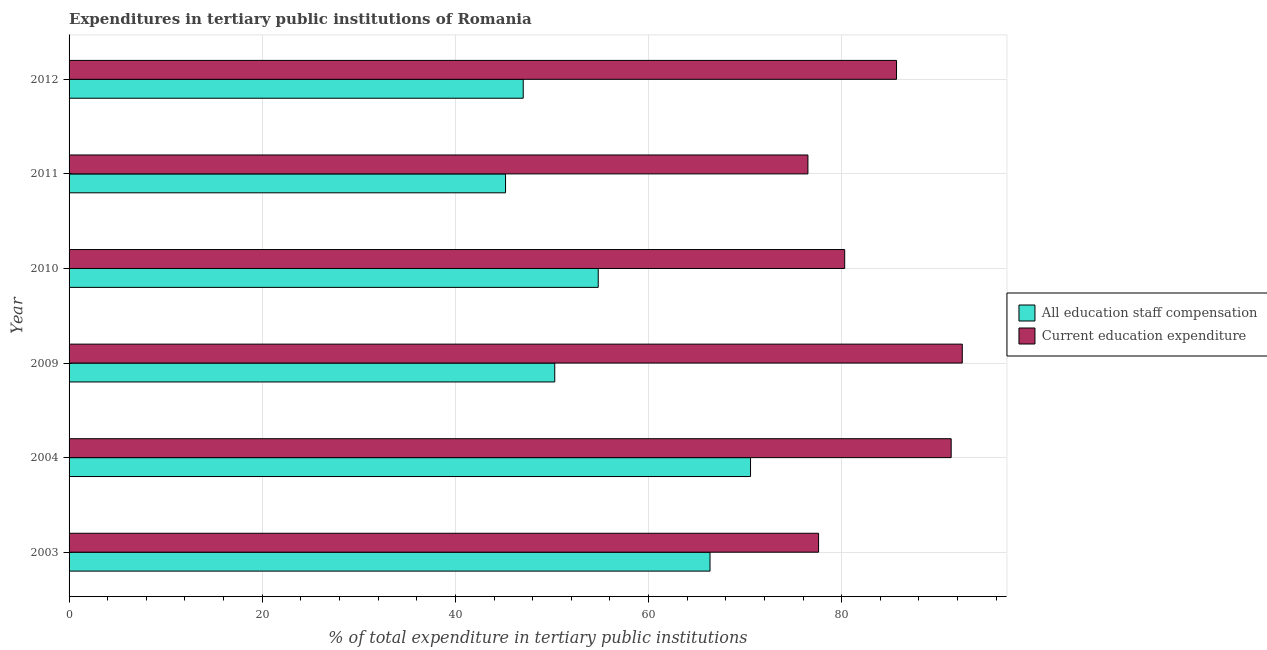How many different coloured bars are there?
Your response must be concise. 2. How many groups of bars are there?
Provide a short and direct response. 6. Are the number of bars on each tick of the Y-axis equal?
Keep it short and to the point. Yes. How many bars are there on the 5th tick from the top?
Offer a terse response. 2. What is the label of the 1st group of bars from the top?
Provide a short and direct response. 2012. In how many cases, is the number of bars for a given year not equal to the number of legend labels?
Ensure brevity in your answer.  0. What is the expenditure in staff compensation in 2011?
Your answer should be very brief. 45.19. Across all years, what is the maximum expenditure in staff compensation?
Give a very brief answer. 70.56. Across all years, what is the minimum expenditure in staff compensation?
Give a very brief answer. 45.19. What is the total expenditure in staff compensation in the graph?
Your response must be concise. 334.21. What is the difference between the expenditure in education in 2010 and that in 2012?
Keep it short and to the point. -5.37. What is the difference between the expenditure in education in 2009 and the expenditure in staff compensation in 2003?
Give a very brief answer. 26.12. What is the average expenditure in education per year?
Your answer should be very brief. 83.98. In the year 2012, what is the difference between the expenditure in education and expenditure in staff compensation?
Your response must be concise. 38.65. In how many years, is the expenditure in education greater than 64 %?
Provide a succinct answer. 6. What is the ratio of the expenditure in staff compensation in 2010 to that in 2011?
Ensure brevity in your answer.  1.21. Is the expenditure in education in 2004 less than that in 2009?
Keep it short and to the point. Yes. What is the difference between the highest and the second highest expenditure in education?
Your answer should be compact. 1.15. What is the difference between the highest and the lowest expenditure in staff compensation?
Give a very brief answer. 25.36. In how many years, is the expenditure in staff compensation greater than the average expenditure in staff compensation taken over all years?
Provide a succinct answer. 2. Is the sum of the expenditure in staff compensation in 2009 and 2010 greater than the maximum expenditure in education across all years?
Make the answer very short. Yes. What does the 1st bar from the top in 2012 represents?
Make the answer very short. Current education expenditure. What does the 2nd bar from the bottom in 2012 represents?
Ensure brevity in your answer.  Current education expenditure. How many bars are there?
Give a very brief answer. 12. Are all the bars in the graph horizontal?
Offer a very short reply. Yes. How many years are there in the graph?
Offer a very short reply. 6. Are the values on the major ticks of X-axis written in scientific E-notation?
Keep it short and to the point. No. Does the graph contain any zero values?
Offer a terse response. No. How many legend labels are there?
Ensure brevity in your answer.  2. How are the legend labels stacked?
Ensure brevity in your answer.  Vertical. What is the title of the graph?
Your answer should be compact. Expenditures in tertiary public institutions of Romania. Does "Death rate" appear as one of the legend labels in the graph?
Your answer should be compact. No. What is the label or title of the X-axis?
Keep it short and to the point. % of total expenditure in tertiary public institutions. What is the % of total expenditure in tertiary public institutions of All education staff compensation in 2003?
Your answer should be compact. 66.36. What is the % of total expenditure in tertiary public institutions of Current education expenditure in 2003?
Keep it short and to the point. 77.6. What is the % of total expenditure in tertiary public institutions of All education staff compensation in 2004?
Your answer should be compact. 70.56. What is the % of total expenditure in tertiary public institutions in Current education expenditure in 2004?
Your response must be concise. 91.33. What is the % of total expenditure in tertiary public institutions in All education staff compensation in 2009?
Your answer should be very brief. 50.29. What is the % of total expenditure in tertiary public institutions in Current education expenditure in 2009?
Your answer should be very brief. 92.48. What is the % of total expenditure in tertiary public institutions of All education staff compensation in 2010?
Your answer should be compact. 54.79. What is the % of total expenditure in tertiary public institutions in Current education expenditure in 2010?
Make the answer very short. 80.31. What is the % of total expenditure in tertiary public institutions in All education staff compensation in 2011?
Your response must be concise. 45.19. What is the % of total expenditure in tertiary public institutions in Current education expenditure in 2011?
Your answer should be compact. 76.5. What is the % of total expenditure in tertiary public institutions in All education staff compensation in 2012?
Provide a succinct answer. 47.02. What is the % of total expenditure in tertiary public institutions of Current education expenditure in 2012?
Offer a very short reply. 85.68. Across all years, what is the maximum % of total expenditure in tertiary public institutions in All education staff compensation?
Make the answer very short. 70.56. Across all years, what is the maximum % of total expenditure in tertiary public institutions in Current education expenditure?
Provide a short and direct response. 92.48. Across all years, what is the minimum % of total expenditure in tertiary public institutions of All education staff compensation?
Offer a very short reply. 45.19. Across all years, what is the minimum % of total expenditure in tertiary public institutions of Current education expenditure?
Keep it short and to the point. 76.5. What is the total % of total expenditure in tertiary public institutions in All education staff compensation in the graph?
Give a very brief answer. 334.21. What is the total % of total expenditure in tertiary public institutions of Current education expenditure in the graph?
Provide a succinct answer. 503.9. What is the difference between the % of total expenditure in tertiary public institutions in All education staff compensation in 2003 and that in 2004?
Keep it short and to the point. -4.2. What is the difference between the % of total expenditure in tertiary public institutions of Current education expenditure in 2003 and that in 2004?
Offer a terse response. -13.73. What is the difference between the % of total expenditure in tertiary public institutions in All education staff compensation in 2003 and that in 2009?
Ensure brevity in your answer.  16.08. What is the difference between the % of total expenditure in tertiary public institutions of Current education expenditure in 2003 and that in 2009?
Provide a short and direct response. -14.88. What is the difference between the % of total expenditure in tertiary public institutions of All education staff compensation in 2003 and that in 2010?
Provide a succinct answer. 11.57. What is the difference between the % of total expenditure in tertiary public institutions in Current education expenditure in 2003 and that in 2010?
Provide a short and direct response. -2.7. What is the difference between the % of total expenditure in tertiary public institutions in All education staff compensation in 2003 and that in 2011?
Give a very brief answer. 21.17. What is the difference between the % of total expenditure in tertiary public institutions in Current education expenditure in 2003 and that in 2011?
Your answer should be compact. 1.1. What is the difference between the % of total expenditure in tertiary public institutions of All education staff compensation in 2003 and that in 2012?
Provide a short and direct response. 19.34. What is the difference between the % of total expenditure in tertiary public institutions in Current education expenditure in 2003 and that in 2012?
Give a very brief answer. -8.07. What is the difference between the % of total expenditure in tertiary public institutions of All education staff compensation in 2004 and that in 2009?
Ensure brevity in your answer.  20.27. What is the difference between the % of total expenditure in tertiary public institutions of Current education expenditure in 2004 and that in 2009?
Make the answer very short. -1.15. What is the difference between the % of total expenditure in tertiary public institutions of All education staff compensation in 2004 and that in 2010?
Your answer should be very brief. 15.77. What is the difference between the % of total expenditure in tertiary public institutions in Current education expenditure in 2004 and that in 2010?
Your answer should be very brief. 11.03. What is the difference between the % of total expenditure in tertiary public institutions of All education staff compensation in 2004 and that in 2011?
Make the answer very short. 25.36. What is the difference between the % of total expenditure in tertiary public institutions of Current education expenditure in 2004 and that in 2011?
Your answer should be very brief. 14.83. What is the difference between the % of total expenditure in tertiary public institutions of All education staff compensation in 2004 and that in 2012?
Give a very brief answer. 23.54. What is the difference between the % of total expenditure in tertiary public institutions of Current education expenditure in 2004 and that in 2012?
Offer a terse response. 5.66. What is the difference between the % of total expenditure in tertiary public institutions in All education staff compensation in 2009 and that in 2010?
Give a very brief answer. -4.5. What is the difference between the % of total expenditure in tertiary public institutions of Current education expenditure in 2009 and that in 2010?
Your answer should be compact. 12.18. What is the difference between the % of total expenditure in tertiary public institutions in All education staff compensation in 2009 and that in 2011?
Your answer should be very brief. 5.09. What is the difference between the % of total expenditure in tertiary public institutions of Current education expenditure in 2009 and that in 2011?
Keep it short and to the point. 15.98. What is the difference between the % of total expenditure in tertiary public institutions in All education staff compensation in 2009 and that in 2012?
Your response must be concise. 3.26. What is the difference between the % of total expenditure in tertiary public institutions of Current education expenditure in 2009 and that in 2012?
Provide a short and direct response. 6.81. What is the difference between the % of total expenditure in tertiary public institutions of All education staff compensation in 2010 and that in 2011?
Your answer should be very brief. 9.6. What is the difference between the % of total expenditure in tertiary public institutions in Current education expenditure in 2010 and that in 2011?
Keep it short and to the point. 3.81. What is the difference between the % of total expenditure in tertiary public institutions in All education staff compensation in 2010 and that in 2012?
Keep it short and to the point. 7.77. What is the difference between the % of total expenditure in tertiary public institutions in Current education expenditure in 2010 and that in 2012?
Your answer should be compact. -5.37. What is the difference between the % of total expenditure in tertiary public institutions of All education staff compensation in 2011 and that in 2012?
Provide a short and direct response. -1.83. What is the difference between the % of total expenditure in tertiary public institutions of Current education expenditure in 2011 and that in 2012?
Your answer should be compact. -9.17. What is the difference between the % of total expenditure in tertiary public institutions of All education staff compensation in 2003 and the % of total expenditure in tertiary public institutions of Current education expenditure in 2004?
Offer a terse response. -24.97. What is the difference between the % of total expenditure in tertiary public institutions in All education staff compensation in 2003 and the % of total expenditure in tertiary public institutions in Current education expenditure in 2009?
Provide a succinct answer. -26.12. What is the difference between the % of total expenditure in tertiary public institutions in All education staff compensation in 2003 and the % of total expenditure in tertiary public institutions in Current education expenditure in 2010?
Provide a short and direct response. -13.94. What is the difference between the % of total expenditure in tertiary public institutions of All education staff compensation in 2003 and the % of total expenditure in tertiary public institutions of Current education expenditure in 2011?
Offer a very short reply. -10.14. What is the difference between the % of total expenditure in tertiary public institutions in All education staff compensation in 2003 and the % of total expenditure in tertiary public institutions in Current education expenditure in 2012?
Make the answer very short. -19.31. What is the difference between the % of total expenditure in tertiary public institutions of All education staff compensation in 2004 and the % of total expenditure in tertiary public institutions of Current education expenditure in 2009?
Your answer should be very brief. -21.93. What is the difference between the % of total expenditure in tertiary public institutions in All education staff compensation in 2004 and the % of total expenditure in tertiary public institutions in Current education expenditure in 2010?
Your answer should be very brief. -9.75. What is the difference between the % of total expenditure in tertiary public institutions of All education staff compensation in 2004 and the % of total expenditure in tertiary public institutions of Current education expenditure in 2011?
Your response must be concise. -5.94. What is the difference between the % of total expenditure in tertiary public institutions of All education staff compensation in 2004 and the % of total expenditure in tertiary public institutions of Current education expenditure in 2012?
Give a very brief answer. -15.12. What is the difference between the % of total expenditure in tertiary public institutions of All education staff compensation in 2009 and the % of total expenditure in tertiary public institutions of Current education expenditure in 2010?
Your response must be concise. -30.02. What is the difference between the % of total expenditure in tertiary public institutions in All education staff compensation in 2009 and the % of total expenditure in tertiary public institutions in Current education expenditure in 2011?
Give a very brief answer. -26.21. What is the difference between the % of total expenditure in tertiary public institutions in All education staff compensation in 2009 and the % of total expenditure in tertiary public institutions in Current education expenditure in 2012?
Offer a very short reply. -35.39. What is the difference between the % of total expenditure in tertiary public institutions of All education staff compensation in 2010 and the % of total expenditure in tertiary public institutions of Current education expenditure in 2011?
Your answer should be very brief. -21.71. What is the difference between the % of total expenditure in tertiary public institutions in All education staff compensation in 2010 and the % of total expenditure in tertiary public institutions in Current education expenditure in 2012?
Your answer should be compact. -30.89. What is the difference between the % of total expenditure in tertiary public institutions of All education staff compensation in 2011 and the % of total expenditure in tertiary public institutions of Current education expenditure in 2012?
Provide a short and direct response. -40.48. What is the average % of total expenditure in tertiary public institutions in All education staff compensation per year?
Offer a terse response. 55.7. What is the average % of total expenditure in tertiary public institutions of Current education expenditure per year?
Make the answer very short. 83.98. In the year 2003, what is the difference between the % of total expenditure in tertiary public institutions in All education staff compensation and % of total expenditure in tertiary public institutions in Current education expenditure?
Keep it short and to the point. -11.24. In the year 2004, what is the difference between the % of total expenditure in tertiary public institutions in All education staff compensation and % of total expenditure in tertiary public institutions in Current education expenditure?
Make the answer very short. -20.78. In the year 2009, what is the difference between the % of total expenditure in tertiary public institutions in All education staff compensation and % of total expenditure in tertiary public institutions in Current education expenditure?
Your answer should be very brief. -42.2. In the year 2010, what is the difference between the % of total expenditure in tertiary public institutions of All education staff compensation and % of total expenditure in tertiary public institutions of Current education expenditure?
Give a very brief answer. -25.52. In the year 2011, what is the difference between the % of total expenditure in tertiary public institutions of All education staff compensation and % of total expenditure in tertiary public institutions of Current education expenditure?
Give a very brief answer. -31.31. In the year 2012, what is the difference between the % of total expenditure in tertiary public institutions of All education staff compensation and % of total expenditure in tertiary public institutions of Current education expenditure?
Make the answer very short. -38.65. What is the ratio of the % of total expenditure in tertiary public institutions in All education staff compensation in 2003 to that in 2004?
Provide a succinct answer. 0.94. What is the ratio of the % of total expenditure in tertiary public institutions of Current education expenditure in 2003 to that in 2004?
Your answer should be compact. 0.85. What is the ratio of the % of total expenditure in tertiary public institutions in All education staff compensation in 2003 to that in 2009?
Your answer should be very brief. 1.32. What is the ratio of the % of total expenditure in tertiary public institutions in Current education expenditure in 2003 to that in 2009?
Provide a short and direct response. 0.84. What is the ratio of the % of total expenditure in tertiary public institutions in All education staff compensation in 2003 to that in 2010?
Ensure brevity in your answer.  1.21. What is the ratio of the % of total expenditure in tertiary public institutions of Current education expenditure in 2003 to that in 2010?
Your answer should be very brief. 0.97. What is the ratio of the % of total expenditure in tertiary public institutions in All education staff compensation in 2003 to that in 2011?
Give a very brief answer. 1.47. What is the ratio of the % of total expenditure in tertiary public institutions of Current education expenditure in 2003 to that in 2011?
Make the answer very short. 1.01. What is the ratio of the % of total expenditure in tertiary public institutions of All education staff compensation in 2003 to that in 2012?
Keep it short and to the point. 1.41. What is the ratio of the % of total expenditure in tertiary public institutions of Current education expenditure in 2003 to that in 2012?
Make the answer very short. 0.91. What is the ratio of the % of total expenditure in tertiary public institutions of All education staff compensation in 2004 to that in 2009?
Your answer should be very brief. 1.4. What is the ratio of the % of total expenditure in tertiary public institutions in Current education expenditure in 2004 to that in 2009?
Your response must be concise. 0.99. What is the ratio of the % of total expenditure in tertiary public institutions of All education staff compensation in 2004 to that in 2010?
Your response must be concise. 1.29. What is the ratio of the % of total expenditure in tertiary public institutions of Current education expenditure in 2004 to that in 2010?
Your answer should be compact. 1.14. What is the ratio of the % of total expenditure in tertiary public institutions in All education staff compensation in 2004 to that in 2011?
Give a very brief answer. 1.56. What is the ratio of the % of total expenditure in tertiary public institutions of Current education expenditure in 2004 to that in 2011?
Keep it short and to the point. 1.19. What is the ratio of the % of total expenditure in tertiary public institutions in All education staff compensation in 2004 to that in 2012?
Your response must be concise. 1.5. What is the ratio of the % of total expenditure in tertiary public institutions in Current education expenditure in 2004 to that in 2012?
Your answer should be compact. 1.07. What is the ratio of the % of total expenditure in tertiary public institutions of All education staff compensation in 2009 to that in 2010?
Your answer should be very brief. 0.92. What is the ratio of the % of total expenditure in tertiary public institutions in Current education expenditure in 2009 to that in 2010?
Give a very brief answer. 1.15. What is the ratio of the % of total expenditure in tertiary public institutions of All education staff compensation in 2009 to that in 2011?
Ensure brevity in your answer.  1.11. What is the ratio of the % of total expenditure in tertiary public institutions in Current education expenditure in 2009 to that in 2011?
Offer a very short reply. 1.21. What is the ratio of the % of total expenditure in tertiary public institutions of All education staff compensation in 2009 to that in 2012?
Ensure brevity in your answer.  1.07. What is the ratio of the % of total expenditure in tertiary public institutions of Current education expenditure in 2009 to that in 2012?
Your answer should be compact. 1.08. What is the ratio of the % of total expenditure in tertiary public institutions of All education staff compensation in 2010 to that in 2011?
Ensure brevity in your answer.  1.21. What is the ratio of the % of total expenditure in tertiary public institutions in Current education expenditure in 2010 to that in 2011?
Give a very brief answer. 1.05. What is the ratio of the % of total expenditure in tertiary public institutions in All education staff compensation in 2010 to that in 2012?
Your answer should be compact. 1.17. What is the ratio of the % of total expenditure in tertiary public institutions of Current education expenditure in 2010 to that in 2012?
Provide a succinct answer. 0.94. What is the ratio of the % of total expenditure in tertiary public institutions of All education staff compensation in 2011 to that in 2012?
Provide a short and direct response. 0.96. What is the ratio of the % of total expenditure in tertiary public institutions of Current education expenditure in 2011 to that in 2012?
Give a very brief answer. 0.89. What is the difference between the highest and the second highest % of total expenditure in tertiary public institutions in All education staff compensation?
Offer a very short reply. 4.2. What is the difference between the highest and the second highest % of total expenditure in tertiary public institutions in Current education expenditure?
Your answer should be compact. 1.15. What is the difference between the highest and the lowest % of total expenditure in tertiary public institutions in All education staff compensation?
Ensure brevity in your answer.  25.36. What is the difference between the highest and the lowest % of total expenditure in tertiary public institutions in Current education expenditure?
Your answer should be compact. 15.98. 